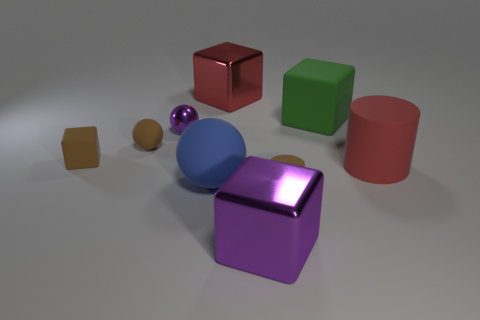What shape is the large thing that is the same color as the small shiny sphere?
Your answer should be compact. Cube. Are there any other things of the same color as the tiny metallic ball?
Keep it short and to the point. Yes. Does the rubber cylinder that is behind the blue sphere have the same color as the big shiny block behind the big red matte object?
Your answer should be very brief. Yes. What size is the matte thing that is both in front of the red cylinder and to the left of the red shiny thing?
Make the answer very short. Large. There is a large ball that is made of the same material as the tiny brown ball; what is its color?
Your response must be concise. Blue. What number of other cylinders are made of the same material as the small cylinder?
Your answer should be very brief. 1. Is the number of brown objects in front of the purple block the same as the number of big blue objects that are behind the blue matte thing?
Your answer should be very brief. Yes. There is a big red rubber thing; does it have the same shape as the big matte object that is to the left of the large purple shiny thing?
Your response must be concise. No. What is the material of the small cylinder that is the same color as the tiny rubber block?
Offer a terse response. Rubber. Is there anything else that is the same shape as the big green matte thing?
Provide a succinct answer. Yes. 